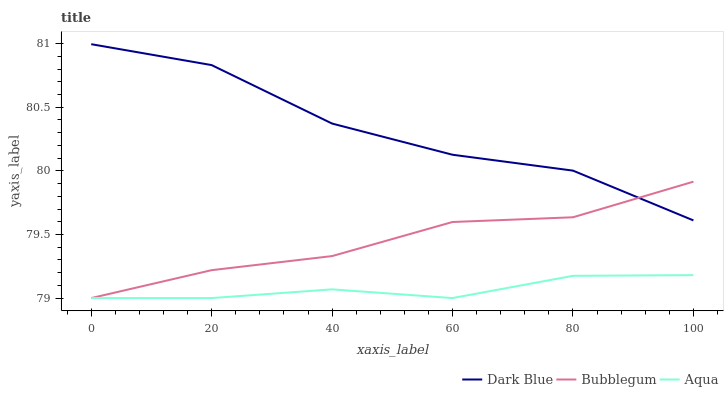Does Bubblegum have the minimum area under the curve?
Answer yes or no. No. Does Bubblegum have the maximum area under the curve?
Answer yes or no. No. Is Bubblegum the smoothest?
Answer yes or no. No. Is Bubblegum the roughest?
Answer yes or no. No. Does Bubblegum have the highest value?
Answer yes or no. No. Is Aqua less than Dark Blue?
Answer yes or no. Yes. Is Dark Blue greater than Aqua?
Answer yes or no. Yes. Does Aqua intersect Dark Blue?
Answer yes or no. No. 